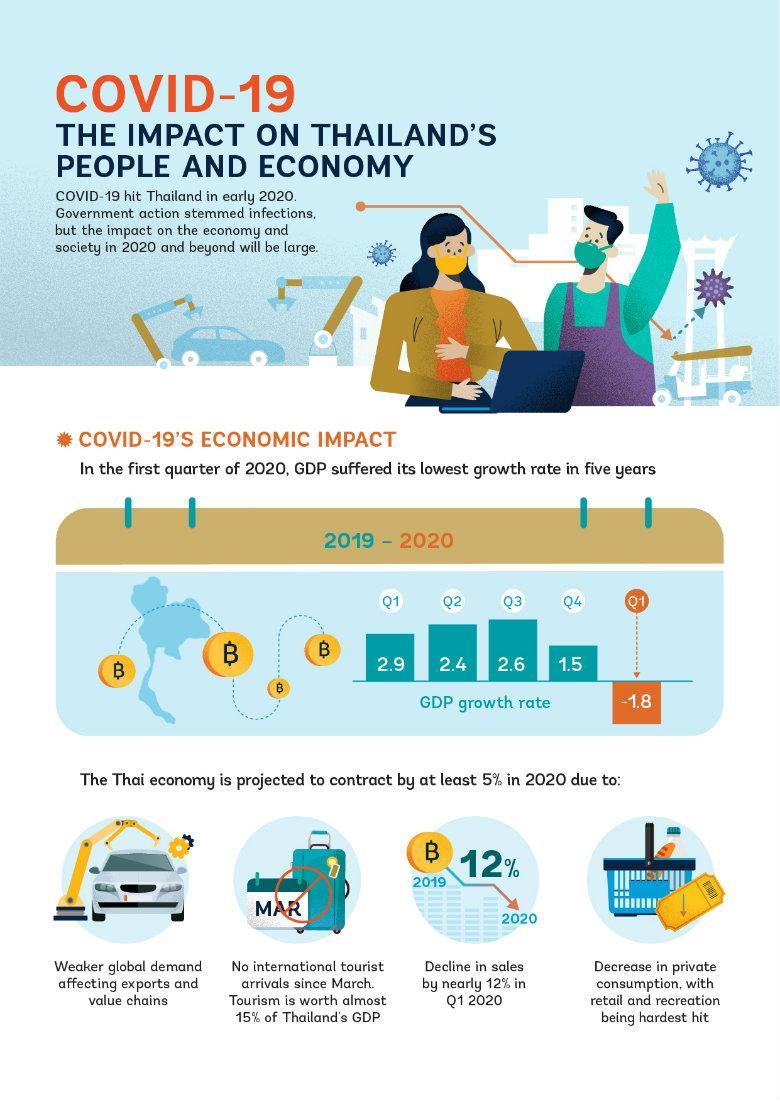What percentage of Thailand's GDP is not contributed by Tourism?
Answer the question with a short phrase. 85 In which quarter second highest GDP of Thailand was recorded? Q3 